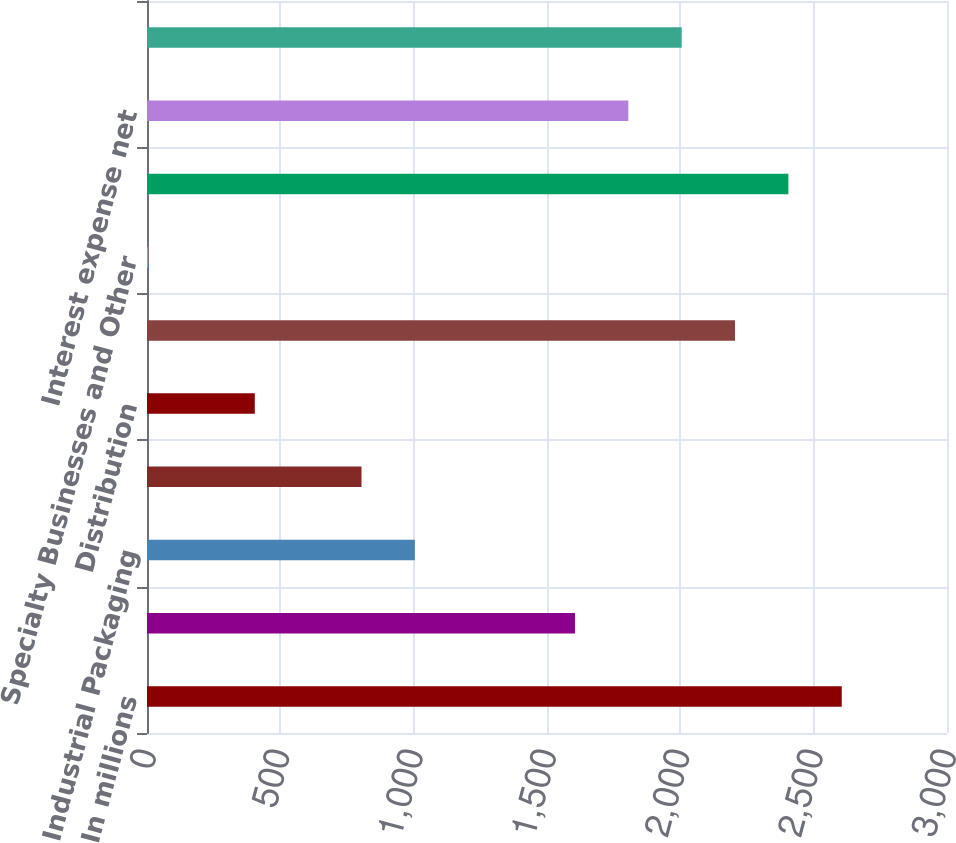<chart> <loc_0><loc_0><loc_500><loc_500><bar_chart><fcel>In millions<fcel>Printing Papers<fcel>Industrial Packaging<fcel>Consumer Packaging<fcel>Distribution<fcel>Forest Products<fcel>Specialty Businesses and Other<fcel>Operating Profit<fcel>Interest expense net<fcel>Corporate items net<nl><fcel>2605.3<fcel>1604.8<fcel>1004.5<fcel>804.4<fcel>404.2<fcel>2205.1<fcel>4<fcel>2405.2<fcel>1804.9<fcel>2005<nl></chart> 